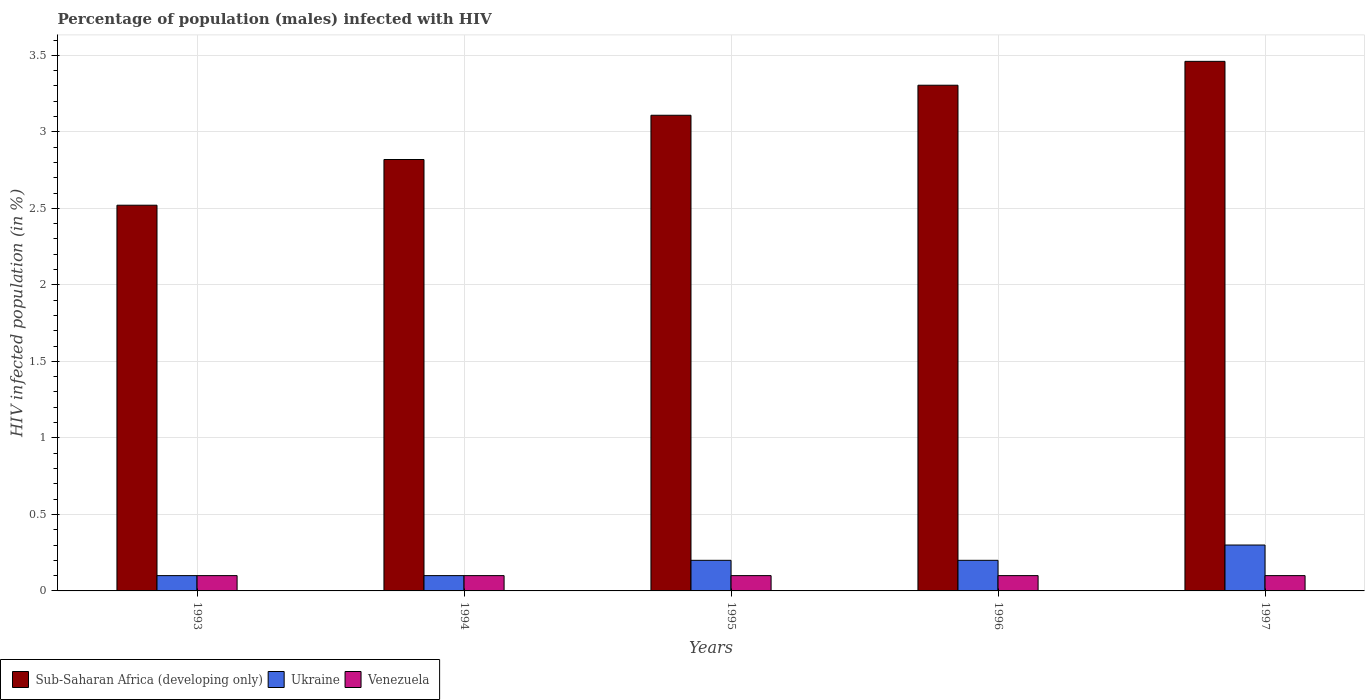How many different coloured bars are there?
Provide a succinct answer. 3. How many groups of bars are there?
Provide a short and direct response. 5. Are the number of bars per tick equal to the number of legend labels?
Offer a terse response. Yes. Are the number of bars on each tick of the X-axis equal?
Give a very brief answer. Yes. How many bars are there on the 4th tick from the right?
Provide a succinct answer. 3. What is the label of the 2nd group of bars from the left?
Make the answer very short. 1994. In how many cases, is the number of bars for a given year not equal to the number of legend labels?
Give a very brief answer. 0. What is the percentage of HIV infected male population in Venezuela in 1995?
Give a very brief answer. 0.1. What is the difference between the percentage of HIV infected male population in Ukraine in 1994 and that in 1996?
Provide a short and direct response. -0.1. What is the average percentage of HIV infected male population in Ukraine per year?
Your response must be concise. 0.18. In the year 1993, what is the difference between the percentage of HIV infected male population in Venezuela and percentage of HIV infected male population in Sub-Saharan Africa (developing only)?
Your response must be concise. -2.42. What is the ratio of the percentage of HIV infected male population in Sub-Saharan Africa (developing only) in 1993 to that in 1997?
Your answer should be compact. 0.73. Is the percentage of HIV infected male population in Venezuela in 1995 less than that in 1997?
Make the answer very short. No. Is the difference between the percentage of HIV infected male population in Venezuela in 1993 and 1995 greater than the difference between the percentage of HIV infected male population in Sub-Saharan Africa (developing only) in 1993 and 1995?
Offer a very short reply. Yes. What is the difference between the highest and the second highest percentage of HIV infected male population in Sub-Saharan Africa (developing only)?
Your answer should be very brief. 0.16. What is the difference between the highest and the lowest percentage of HIV infected male population in Venezuela?
Your answer should be compact. 0. In how many years, is the percentage of HIV infected male population in Venezuela greater than the average percentage of HIV infected male population in Venezuela taken over all years?
Make the answer very short. 0. What does the 3rd bar from the left in 1993 represents?
Your response must be concise. Venezuela. What does the 1st bar from the right in 1995 represents?
Provide a succinct answer. Venezuela. Is it the case that in every year, the sum of the percentage of HIV infected male population in Sub-Saharan Africa (developing only) and percentage of HIV infected male population in Ukraine is greater than the percentage of HIV infected male population in Venezuela?
Offer a very short reply. Yes. Are all the bars in the graph horizontal?
Provide a short and direct response. No. Does the graph contain any zero values?
Ensure brevity in your answer.  No. Where does the legend appear in the graph?
Ensure brevity in your answer.  Bottom left. What is the title of the graph?
Make the answer very short. Percentage of population (males) infected with HIV. What is the label or title of the Y-axis?
Offer a terse response. HIV infected population (in %). What is the HIV infected population (in %) of Sub-Saharan Africa (developing only) in 1993?
Your response must be concise. 2.52. What is the HIV infected population (in %) in Ukraine in 1993?
Give a very brief answer. 0.1. What is the HIV infected population (in %) of Venezuela in 1993?
Keep it short and to the point. 0.1. What is the HIV infected population (in %) of Sub-Saharan Africa (developing only) in 1994?
Give a very brief answer. 2.82. What is the HIV infected population (in %) in Ukraine in 1994?
Offer a very short reply. 0.1. What is the HIV infected population (in %) of Sub-Saharan Africa (developing only) in 1995?
Ensure brevity in your answer.  3.11. What is the HIV infected population (in %) of Sub-Saharan Africa (developing only) in 1996?
Keep it short and to the point. 3.3. What is the HIV infected population (in %) of Sub-Saharan Africa (developing only) in 1997?
Keep it short and to the point. 3.46. What is the HIV infected population (in %) of Ukraine in 1997?
Offer a terse response. 0.3. Across all years, what is the maximum HIV infected population (in %) in Sub-Saharan Africa (developing only)?
Keep it short and to the point. 3.46. Across all years, what is the maximum HIV infected population (in %) of Ukraine?
Provide a succinct answer. 0.3. Across all years, what is the maximum HIV infected population (in %) of Venezuela?
Provide a short and direct response. 0.1. Across all years, what is the minimum HIV infected population (in %) in Sub-Saharan Africa (developing only)?
Ensure brevity in your answer.  2.52. Across all years, what is the minimum HIV infected population (in %) of Ukraine?
Offer a very short reply. 0.1. Across all years, what is the minimum HIV infected population (in %) in Venezuela?
Offer a very short reply. 0.1. What is the total HIV infected population (in %) in Sub-Saharan Africa (developing only) in the graph?
Your response must be concise. 15.21. What is the total HIV infected population (in %) of Ukraine in the graph?
Your answer should be compact. 0.9. What is the total HIV infected population (in %) of Venezuela in the graph?
Your response must be concise. 0.5. What is the difference between the HIV infected population (in %) in Sub-Saharan Africa (developing only) in 1993 and that in 1994?
Keep it short and to the point. -0.3. What is the difference between the HIV infected population (in %) in Ukraine in 1993 and that in 1994?
Your response must be concise. 0. What is the difference between the HIV infected population (in %) of Venezuela in 1993 and that in 1994?
Your response must be concise. 0. What is the difference between the HIV infected population (in %) in Sub-Saharan Africa (developing only) in 1993 and that in 1995?
Your answer should be compact. -0.59. What is the difference between the HIV infected population (in %) of Ukraine in 1993 and that in 1995?
Keep it short and to the point. -0.1. What is the difference between the HIV infected population (in %) of Sub-Saharan Africa (developing only) in 1993 and that in 1996?
Keep it short and to the point. -0.78. What is the difference between the HIV infected population (in %) in Ukraine in 1993 and that in 1996?
Offer a terse response. -0.1. What is the difference between the HIV infected population (in %) in Sub-Saharan Africa (developing only) in 1993 and that in 1997?
Offer a terse response. -0.94. What is the difference between the HIV infected population (in %) of Venezuela in 1993 and that in 1997?
Make the answer very short. 0. What is the difference between the HIV infected population (in %) in Sub-Saharan Africa (developing only) in 1994 and that in 1995?
Offer a very short reply. -0.29. What is the difference between the HIV infected population (in %) in Ukraine in 1994 and that in 1995?
Give a very brief answer. -0.1. What is the difference between the HIV infected population (in %) of Venezuela in 1994 and that in 1995?
Your response must be concise. 0. What is the difference between the HIV infected population (in %) in Sub-Saharan Africa (developing only) in 1994 and that in 1996?
Provide a short and direct response. -0.49. What is the difference between the HIV infected population (in %) in Ukraine in 1994 and that in 1996?
Your answer should be very brief. -0.1. What is the difference between the HIV infected population (in %) of Sub-Saharan Africa (developing only) in 1994 and that in 1997?
Give a very brief answer. -0.64. What is the difference between the HIV infected population (in %) of Ukraine in 1994 and that in 1997?
Ensure brevity in your answer.  -0.2. What is the difference between the HIV infected population (in %) in Sub-Saharan Africa (developing only) in 1995 and that in 1996?
Offer a terse response. -0.2. What is the difference between the HIV infected population (in %) of Ukraine in 1995 and that in 1996?
Give a very brief answer. 0. What is the difference between the HIV infected population (in %) of Sub-Saharan Africa (developing only) in 1995 and that in 1997?
Make the answer very short. -0.35. What is the difference between the HIV infected population (in %) in Sub-Saharan Africa (developing only) in 1996 and that in 1997?
Keep it short and to the point. -0.16. What is the difference between the HIV infected population (in %) of Sub-Saharan Africa (developing only) in 1993 and the HIV infected population (in %) of Ukraine in 1994?
Offer a very short reply. 2.42. What is the difference between the HIV infected population (in %) in Sub-Saharan Africa (developing only) in 1993 and the HIV infected population (in %) in Venezuela in 1994?
Your response must be concise. 2.42. What is the difference between the HIV infected population (in %) in Sub-Saharan Africa (developing only) in 1993 and the HIV infected population (in %) in Ukraine in 1995?
Offer a terse response. 2.32. What is the difference between the HIV infected population (in %) of Sub-Saharan Africa (developing only) in 1993 and the HIV infected population (in %) of Venezuela in 1995?
Provide a short and direct response. 2.42. What is the difference between the HIV infected population (in %) in Ukraine in 1993 and the HIV infected population (in %) in Venezuela in 1995?
Your response must be concise. 0. What is the difference between the HIV infected population (in %) of Sub-Saharan Africa (developing only) in 1993 and the HIV infected population (in %) of Ukraine in 1996?
Ensure brevity in your answer.  2.32. What is the difference between the HIV infected population (in %) in Sub-Saharan Africa (developing only) in 1993 and the HIV infected population (in %) in Venezuela in 1996?
Offer a very short reply. 2.42. What is the difference between the HIV infected population (in %) of Ukraine in 1993 and the HIV infected population (in %) of Venezuela in 1996?
Your answer should be very brief. 0. What is the difference between the HIV infected population (in %) in Sub-Saharan Africa (developing only) in 1993 and the HIV infected population (in %) in Ukraine in 1997?
Your answer should be very brief. 2.22. What is the difference between the HIV infected population (in %) in Sub-Saharan Africa (developing only) in 1993 and the HIV infected population (in %) in Venezuela in 1997?
Keep it short and to the point. 2.42. What is the difference between the HIV infected population (in %) of Sub-Saharan Africa (developing only) in 1994 and the HIV infected population (in %) of Ukraine in 1995?
Offer a terse response. 2.62. What is the difference between the HIV infected population (in %) in Sub-Saharan Africa (developing only) in 1994 and the HIV infected population (in %) in Venezuela in 1995?
Your answer should be compact. 2.72. What is the difference between the HIV infected population (in %) of Ukraine in 1994 and the HIV infected population (in %) of Venezuela in 1995?
Your response must be concise. 0. What is the difference between the HIV infected population (in %) of Sub-Saharan Africa (developing only) in 1994 and the HIV infected population (in %) of Ukraine in 1996?
Offer a terse response. 2.62. What is the difference between the HIV infected population (in %) in Sub-Saharan Africa (developing only) in 1994 and the HIV infected population (in %) in Venezuela in 1996?
Your answer should be very brief. 2.72. What is the difference between the HIV infected population (in %) in Ukraine in 1994 and the HIV infected population (in %) in Venezuela in 1996?
Your response must be concise. 0. What is the difference between the HIV infected population (in %) in Sub-Saharan Africa (developing only) in 1994 and the HIV infected population (in %) in Ukraine in 1997?
Make the answer very short. 2.52. What is the difference between the HIV infected population (in %) of Sub-Saharan Africa (developing only) in 1994 and the HIV infected population (in %) of Venezuela in 1997?
Your answer should be very brief. 2.72. What is the difference between the HIV infected population (in %) of Sub-Saharan Africa (developing only) in 1995 and the HIV infected population (in %) of Ukraine in 1996?
Provide a succinct answer. 2.91. What is the difference between the HIV infected population (in %) in Sub-Saharan Africa (developing only) in 1995 and the HIV infected population (in %) in Venezuela in 1996?
Ensure brevity in your answer.  3.01. What is the difference between the HIV infected population (in %) of Ukraine in 1995 and the HIV infected population (in %) of Venezuela in 1996?
Give a very brief answer. 0.1. What is the difference between the HIV infected population (in %) in Sub-Saharan Africa (developing only) in 1995 and the HIV infected population (in %) in Ukraine in 1997?
Provide a short and direct response. 2.81. What is the difference between the HIV infected population (in %) of Sub-Saharan Africa (developing only) in 1995 and the HIV infected population (in %) of Venezuela in 1997?
Your answer should be very brief. 3.01. What is the difference between the HIV infected population (in %) in Ukraine in 1995 and the HIV infected population (in %) in Venezuela in 1997?
Provide a succinct answer. 0.1. What is the difference between the HIV infected population (in %) of Sub-Saharan Africa (developing only) in 1996 and the HIV infected population (in %) of Ukraine in 1997?
Your answer should be very brief. 3. What is the difference between the HIV infected population (in %) in Sub-Saharan Africa (developing only) in 1996 and the HIV infected population (in %) in Venezuela in 1997?
Provide a succinct answer. 3.2. What is the difference between the HIV infected population (in %) of Ukraine in 1996 and the HIV infected population (in %) of Venezuela in 1997?
Give a very brief answer. 0.1. What is the average HIV infected population (in %) of Sub-Saharan Africa (developing only) per year?
Offer a very short reply. 3.04. What is the average HIV infected population (in %) of Ukraine per year?
Make the answer very short. 0.18. What is the average HIV infected population (in %) of Venezuela per year?
Your answer should be very brief. 0.1. In the year 1993, what is the difference between the HIV infected population (in %) of Sub-Saharan Africa (developing only) and HIV infected population (in %) of Ukraine?
Offer a terse response. 2.42. In the year 1993, what is the difference between the HIV infected population (in %) in Sub-Saharan Africa (developing only) and HIV infected population (in %) in Venezuela?
Your answer should be very brief. 2.42. In the year 1994, what is the difference between the HIV infected population (in %) of Sub-Saharan Africa (developing only) and HIV infected population (in %) of Ukraine?
Offer a terse response. 2.72. In the year 1994, what is the difference between the HIV infected population (in %) of Sub-Saharan Africa (developing only) and HIV infected population (in %) of Venezuela?
Offer a very short reply. 2.72. In the year 1995, what is the difference between the HIV infected population (in %) in Sub-Saharan Africa (developing only) and HIV infected population (in %) in Ukraine?
Offer a terse response. 2.91. In the year 1995, what is the difference between the HIV infected population (in %) of Sub-Saharan Africa (developing only) and HIV infected population (in %) of Venezuela?
Make the answer very short. 3.01. In the year 1995, what is the difference between the HIV infected population (in %) of Ukraine and HIV infected population (in %) of Venezuela?
Give a very brief answer. 0.1. In the year 1996, what is the difference between the HIV infected population (in %) of Sub-Saharan Africa (developing only) and HIV infected population (in %) of Ukraine?
Offer a very short reply. 3.1. In the year 1996, what is the difference between the HIV infected population (in %) in Sub-Saharan Africa (developing only) and HIV infected population (in %) in Venezuela?
Your response must be concise. 3.2. In the year 1996, what is the difference between the HIV infected population (in %) in Ukraine and HIV infected population (in %) in Venezuela?
Offer a terse response. 0.1. In the year 1997, what is the difference between the HIV infected population (in %) in Sub-Saharan Africa (developing only) and HIV infected population (in %) in Ukraine?
Your answer should be compact. 3.16. In the year 1997, what is the difference between the HIV infected population (in %) of Sub-Saharan Africa (developing only) and HIV infected population (in %) of Venezuela?
Provide a short and direct response. 3.36. In the year 1997, what is the difference between the HIV infected population (in %) in Ukraine and HIV infected population (in %) in Venezuela?
Make the answer very short. 0.2. What is the ratio of the HIV infected population (in %) of Sub-Saharan Africa (developing only) in 1993 to that in 1994?
Your answer should be compact. 0.89. What is the ratio of the HIV infected population (in %) in Ukraine in 1993 to that in 1994?
Your response must be concise. 1. What is the ratio of the HIV infected population (in %) in Venezuela in 1993 to that in 1994?
Ensure brevity in your answer.  1. What is the ratio of the HIV infected population (in %) in Sub-Saharan Africa (developing only) in 1993 to that in 1995?
Your response must be concise. 0.81. What is the ratio of the HIV infected population (in %) of Ukraine in 1993 to that in 1995?
Your answer should be compact. 0.5. What is the ratio of the HIV infected population (in %) of Venezuela in 1993 to that in 1995?
Ensure brevity in your answer.  1. What is the ratio of the HIV infected population (in %) in Sub-Saharan Africa (developing only) in 1993 to that in 1996?
Give a very brief answer. 0.76. What is the ratio of the HIV infected population (in %) in Ukraine in 1993 to that in 1996?
Make the answer very short. 0.5. What is the ratio of the HIV infected population (in %) of Venezuela in 1993 to that in 1996?
Offer a terse response. 1. What is the ratio of the HIV infected population (in %) of Sub-Saharan Africa (developing only) in 1993 to that in 1997?
Provide a short and direct response. 0.73. What is the ratio of the HIV infected population (in %) in Venezuela in 1993 to that in 1997?
Your answer should be very brief. 1. What is the ratio of the HIV infected population (in %) in Sub-Saharan Africa (developing only) in 1994 to that in 1995?
Keep it short and to the point. 0.91. What is the ratio of the HIV infected population (in %) of Sub-Saharan Africa (developing only) in 1994 to that in 1996?
Your answer should be very brief. 0.85. What is the ratio of the HIV infected population (in %) in Ukraine in 1994 to that in 1996?
Keep it short and to the point. 0.5. What is the ratio of the HIV infected population (in %) of Venezuela in 1994 to that in 1996?
Make the answer very short. 1. What is the ratio of the HIV infected population (in %) in Sub-Saharan Africa (developing only) in 1994 to that in 1997?
Your answer should be compact. 0.81. What is the ratio of the HIV infected population (in %) of Venezuela in 1994 to that in 1997?
Offer a terse response. 1. What is the ratio of the HIV infected population (in %) in Sub-Saharan Africa (developing only) in 1995 to that in 1996?
Your answer should be very brief. 0.94. What is the ratio of the HIV infected population (in %) of Venezuela in 1995 to that in 1996?
Offer a terse response. 1. What is the ratio of the HIV infected population (in %) of Sub-Saharan Africa (developing only) in 1995 to that in 1997?
Keep it short and to the point. 0.9. What is the ratio of the HIV infected population (in %) in Ukraine in 1995 to that in 1997?
Your answer should be compact. 0.67. What is the ratio of the HIV infected population (in %) in Sub-Saharan Africa (developing only) in 1996 to that in 1997?
Offer a terse response. 0.95. What is the ratio of the HIV infected population (in %) of Ukraine in 1996 to that in 1997?
Offer a very short reply. 0.67. What is the difference between the highest and the second highest HIV infected population (in %) in Sub-Saharan Africa (developing only)?
Give a very brief answer. 0.16. What is the difference between the highest and the second highest HIV infected population (in %) in Ukraine?
Offer a very short reply. 0.1. What is the difference between the highest and the lowest HIV infected population (in %) in Sub-Saharan Africa (developing only)?
Your answer should be compact. 0.94. What is the difference between the highest and the lowest HIV infected population (in %) of Ukraine?
Make the answer very short. 0.2. 